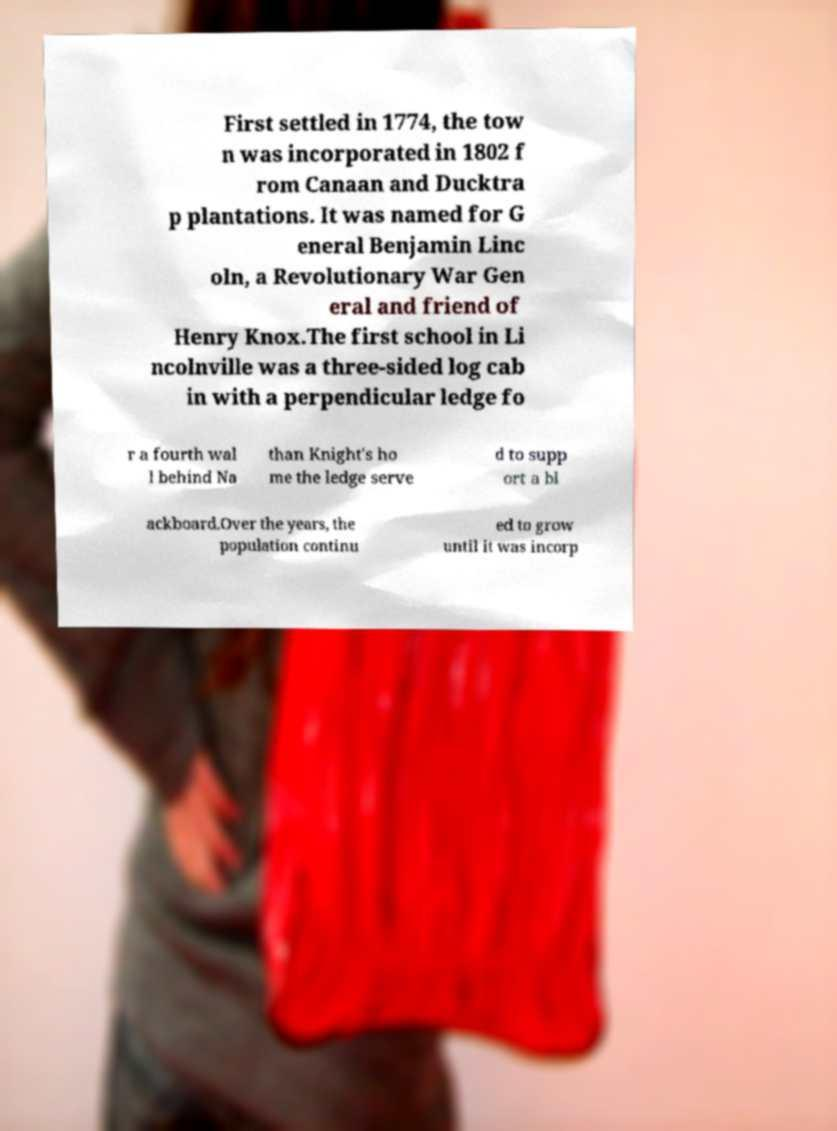Please identify and transcribe the text found in this image. First settled in 1774, the tow n was incorporated in 1802 f rom Canaan and Ducktra p plantations. It was named for G eneral Benjamin Linc oln, a Revolutionary War Gen eral and friend of Henry Knox.The first school in Li ncolnville was a three-sided log cab in with a perpendicular ledge fo r a fourth wal l behind Na than Knight's ho me the ledge serve d to supp ort a bl ackboard.Over the years, the population continu ed to grow until it was incorp 